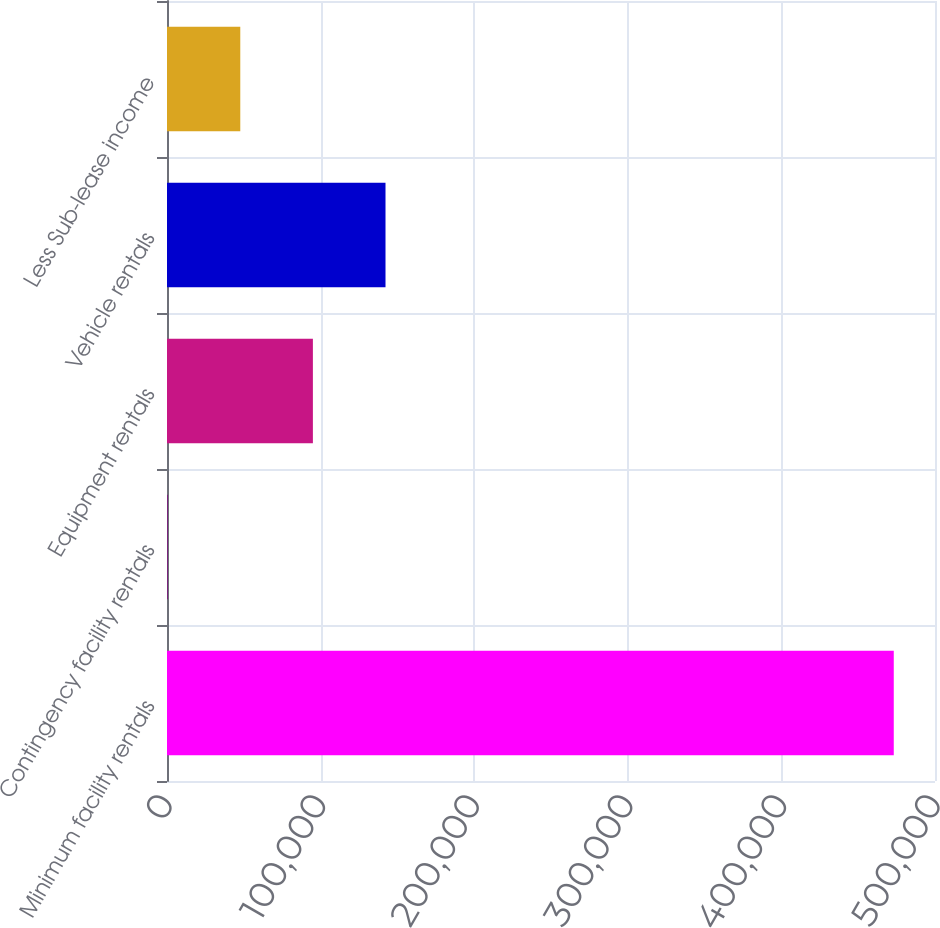Convert chart to OTSL. <chart><loc_0><loc_0><loc_500><loc_500><bar_chart><fcel>Minimum facility rentals<fcel>Contingency facility rentals<fcel>Equipment rentals<fcel>Vehicle rentals<fcel>Less Sub-lease income<nl><fcel>473156<fcel>440<fcel>94983.2<fcel>142255<fcel>47711.6<nl></chart> 